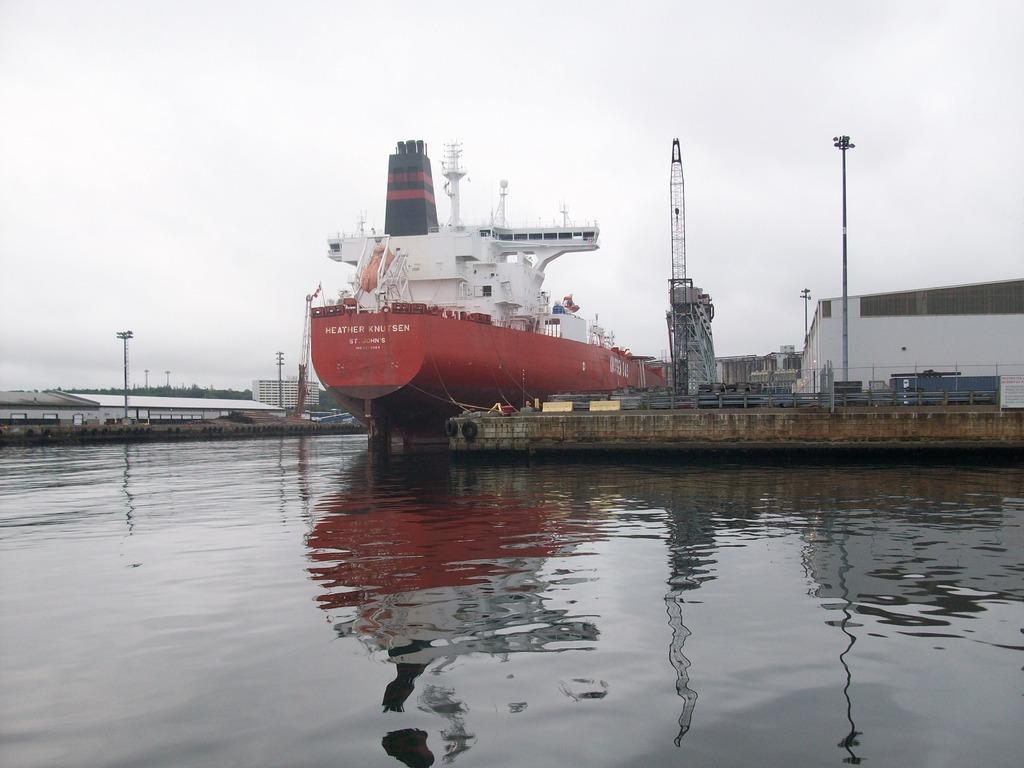What is the first name of the boat?
Your answer should be very brief. Heather. 